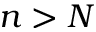Convert formula to latex. <formula><loc_0><loc_0><loc_500><loc_500>n > N</formula> 